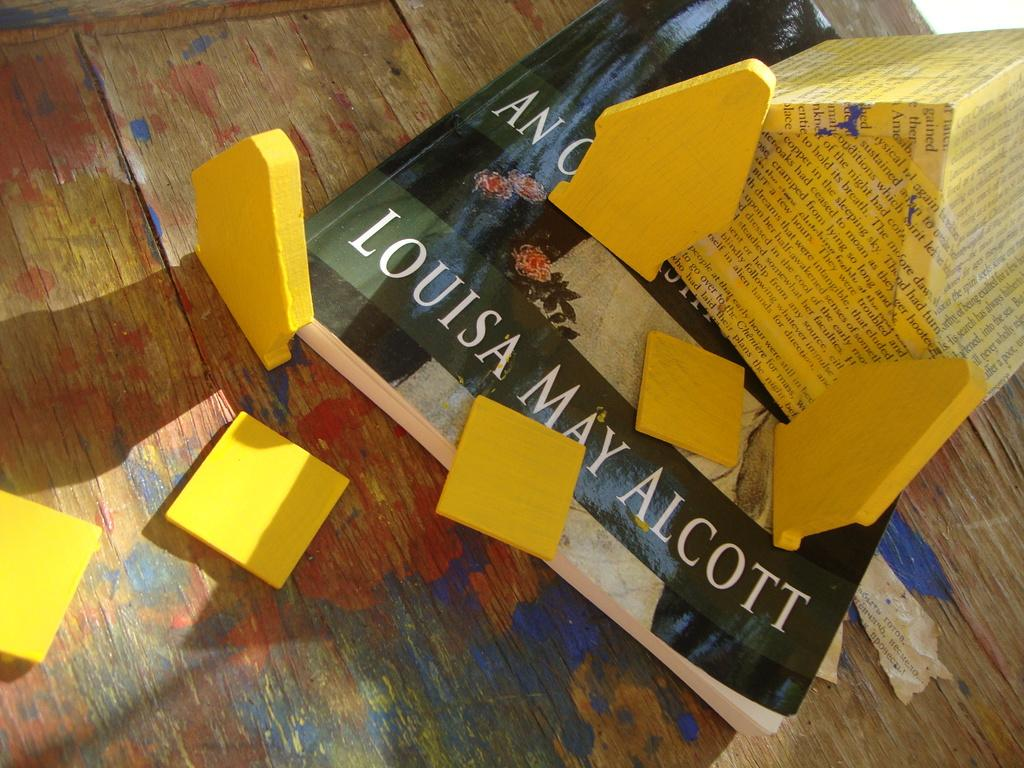<image>
Describe the image concisely. Several yellow wood blocks are sitting on a book by Louisa May Alcott. 